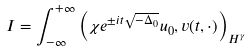Convert formula to latex. <formula><loc_0><loc_0><loc_500><loc_500>I = \int _ { - \infty } ^ { + \infty } \left ( \chi e ^ { \pm i t \sqrt { - \Delta _ { 0 } } } u _ { 0 } , v ( t , \cdot ) \right ) _ { { H } ^ { \gamma } }</formula> 